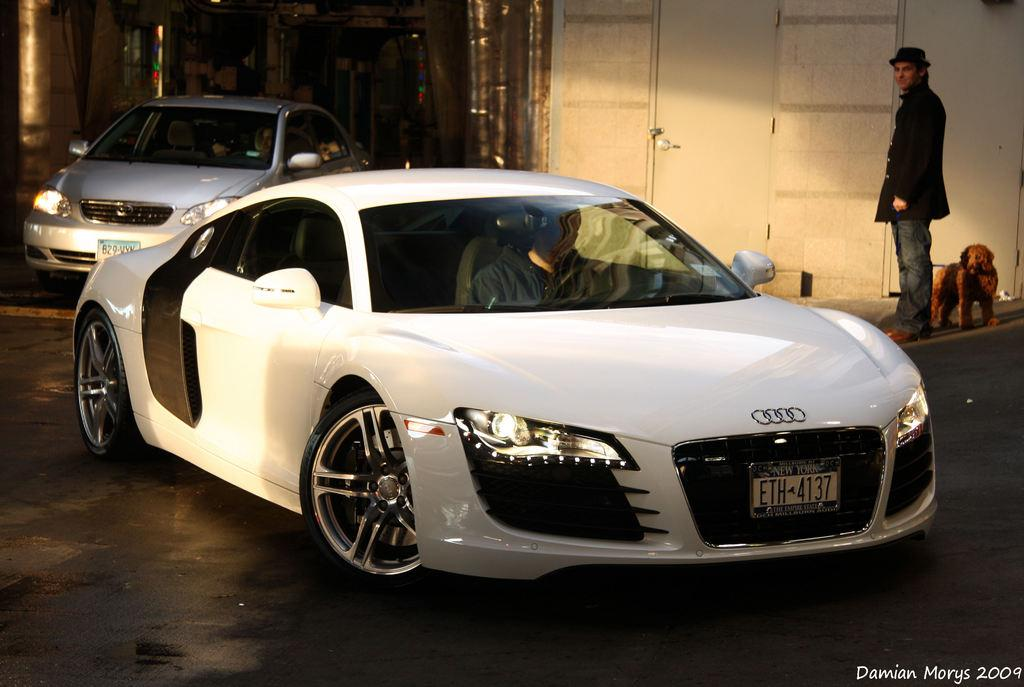How many cars are in the image? There are two cars in the image. Are there any people inside the cars? Yes, there are persons inside the cars. What can be seen on the right side of the image? There is a person, a dog, a door, and a wall on the right side of the image. Is there any text visible in the image? Yes, there is text in the bottom right corner of the image. How many patches of grass are visible in the image? There is no grass visible in the image; it features two cars, persons inside the cars, a person, a dog, a door, a wall, and text in the bottom right corner. 